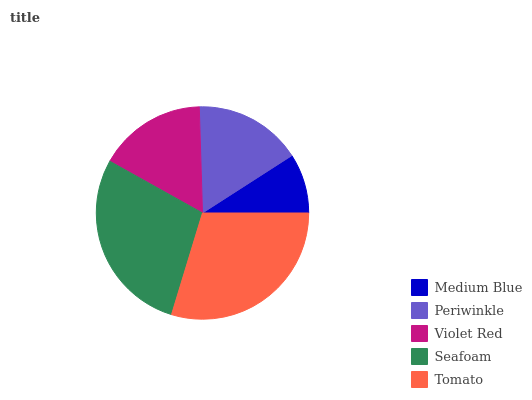Is Medium Blue the minimum?
Answer yes or no. Yes. Is Tomato the maximum?
Answer yes or no. Yes. Is Periwinkle the minimum?
Answer yes or no. No. Is Periwinkle the maximum?
Answer yes or no. No. Is Periwinkle greater than Medium Blue?
Answer yes or no. Yes. Is Medium Blue less than Periwinkle?
Answer yes or no. Yes. Is Medium Blue greater than Periwinkle?
Answer yes or no. No. Is Periwinkle less than Medium Blue?
Answer yes or no. No. Is Violet Red the high median?
Answer yes or no. Yes. Is Violet Red the low median?
Answer yes or no. Yes. Is Medium Blue the high median?
Answer yes or no. No. Is Tomato the low median?
Answer yes or no. No. 